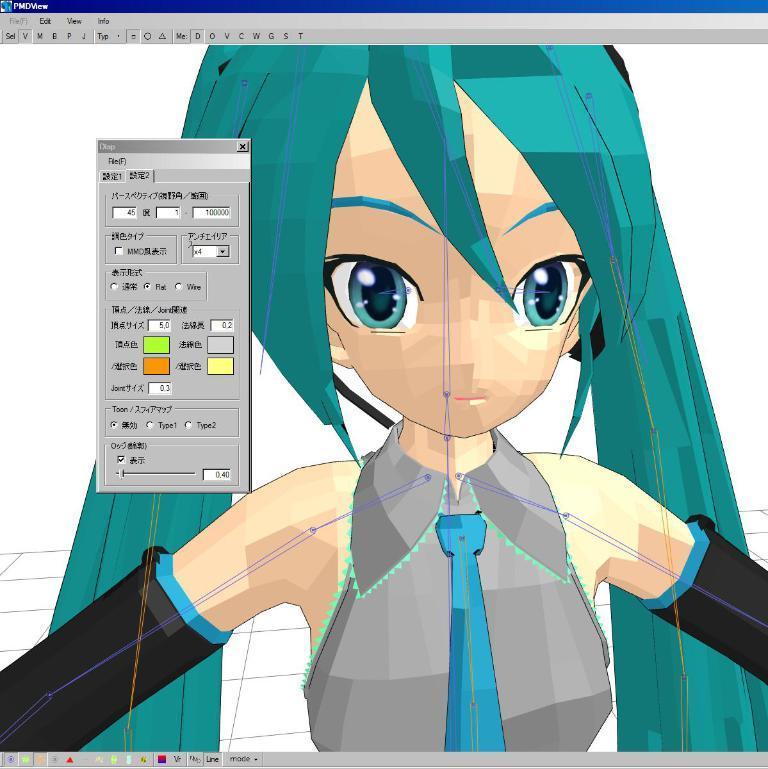How would you summarize this image in a sentence or two? In this picture there is an image of a girl and there is a small tab beside it. 